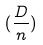Convert formula to latex. <formula><loc_0><loc_0><loc_500><loc_500>( \frac { D } { n } )</formula> 